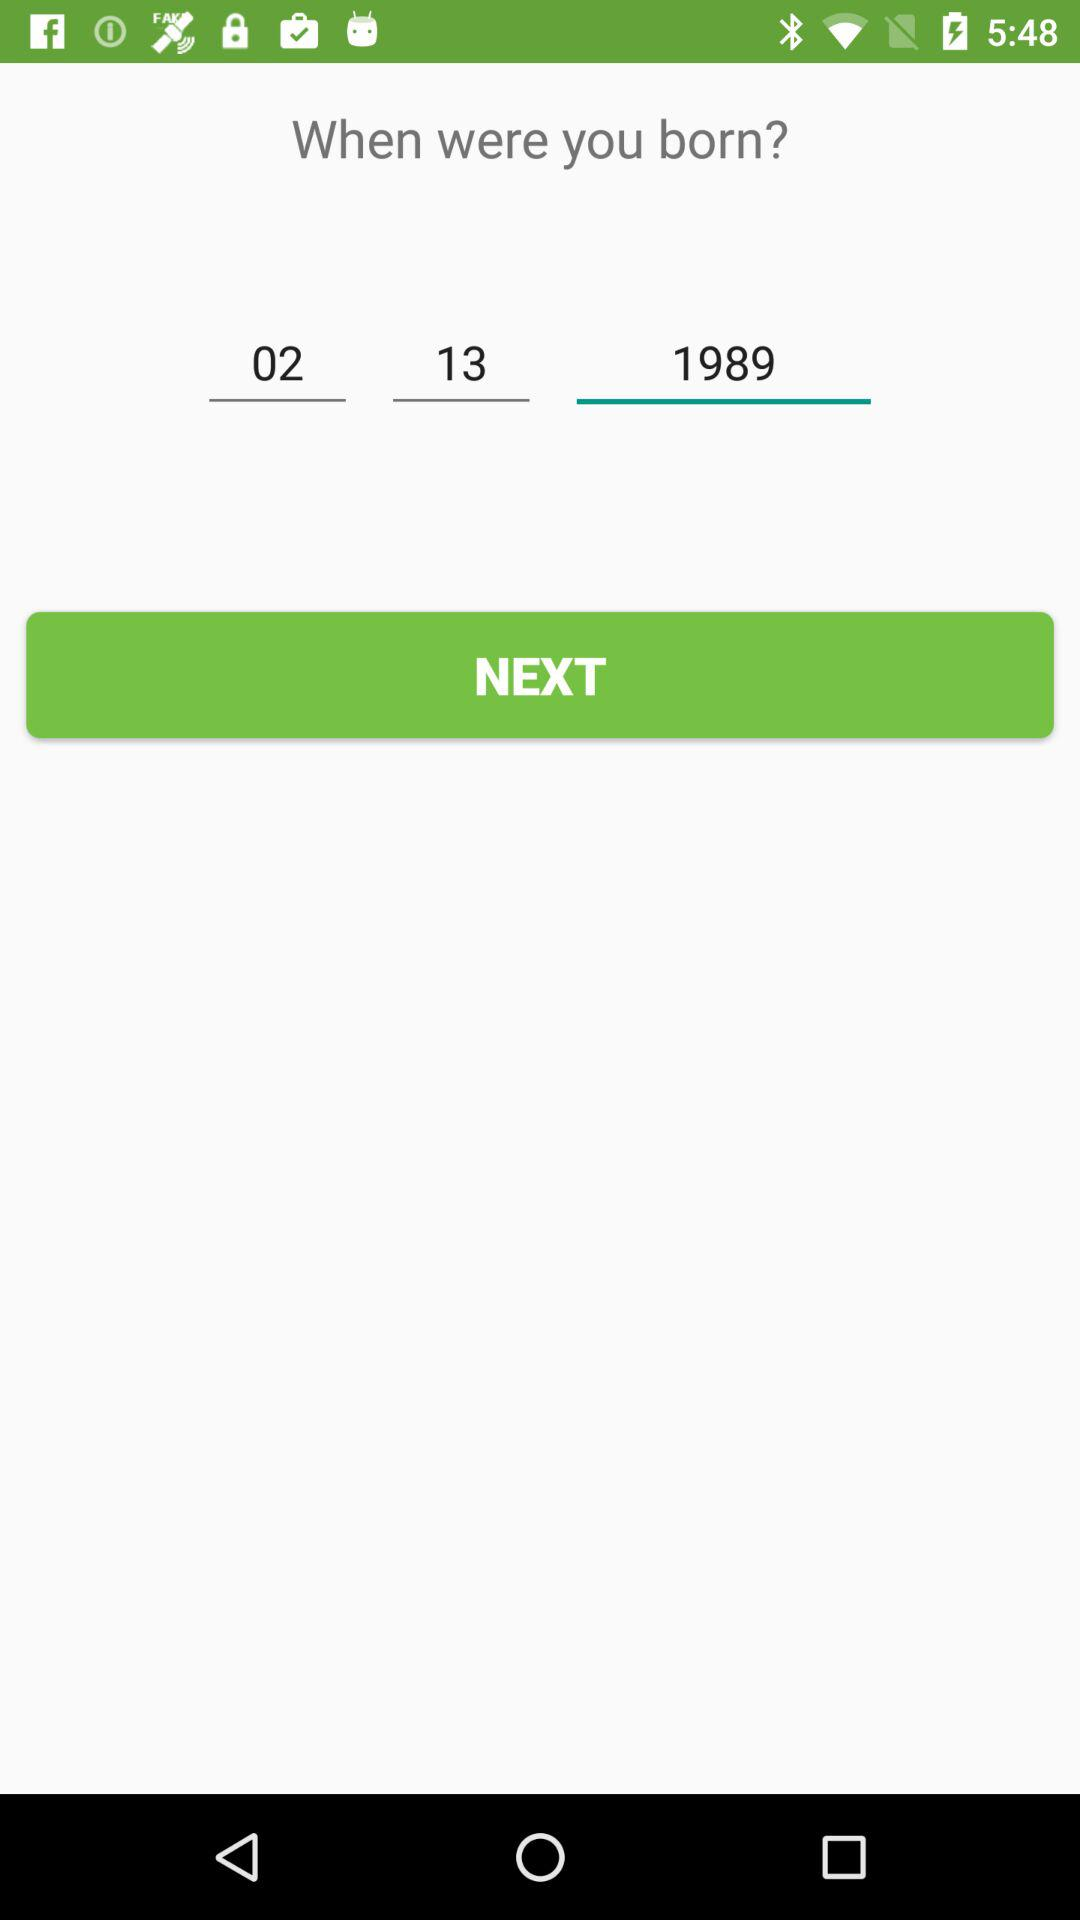How many digits are in the year of birth that was input?
Answer the question using a single word or phrase. 4 